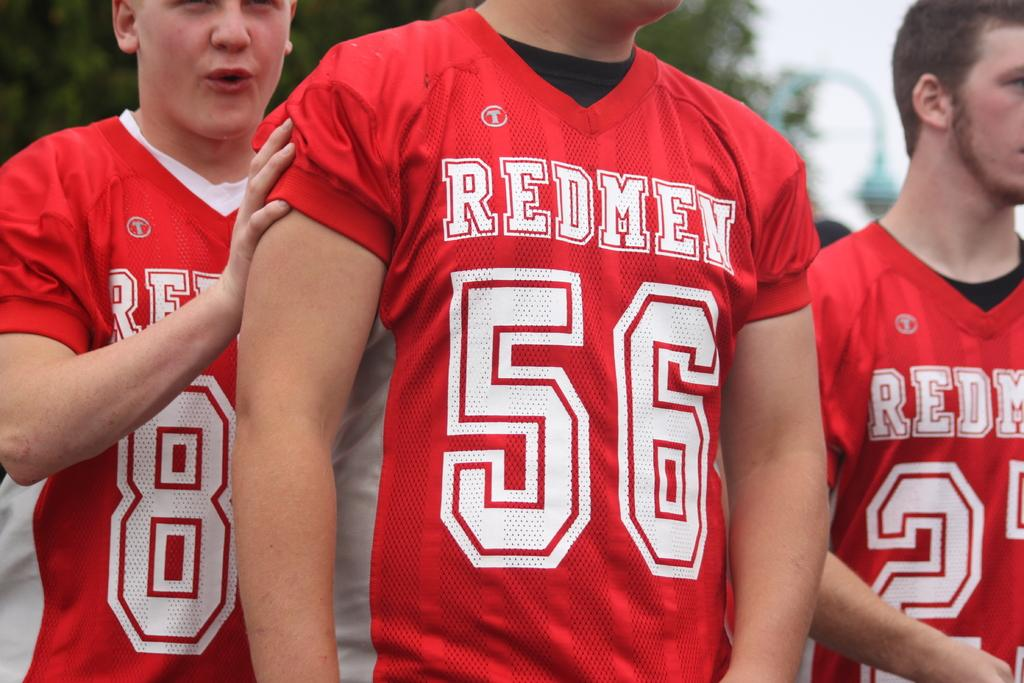<image>
Share a concise interpretation of the image provided. A football player in red wearing a number 56 jersey alongside two teammates. 